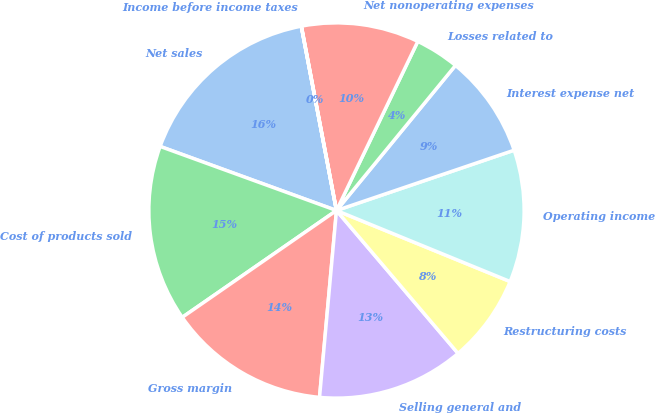<chart> <loc_0><loc_0><loc_500><loc_500><pie_chart><fcel>Net sales<fcel>Cost of products sold<fcel>Gross margin<fcel>Selling general and<fcel>Restructuring costs<fcel>Operating income<fcel>Interest expense net<fcel>Losses related to<fcel>Net nonoperating expenses<fcel>Income before income taxes<nl><fcel>16.45%<fcel>15.19%<fcel>13.92%<fcel>12.66%<fcel>7.6%<fcel>11.39%<fcel>8.86%<fcel>3.8%<fcel>10.13%<fcel>0.01%<nl></chart> 